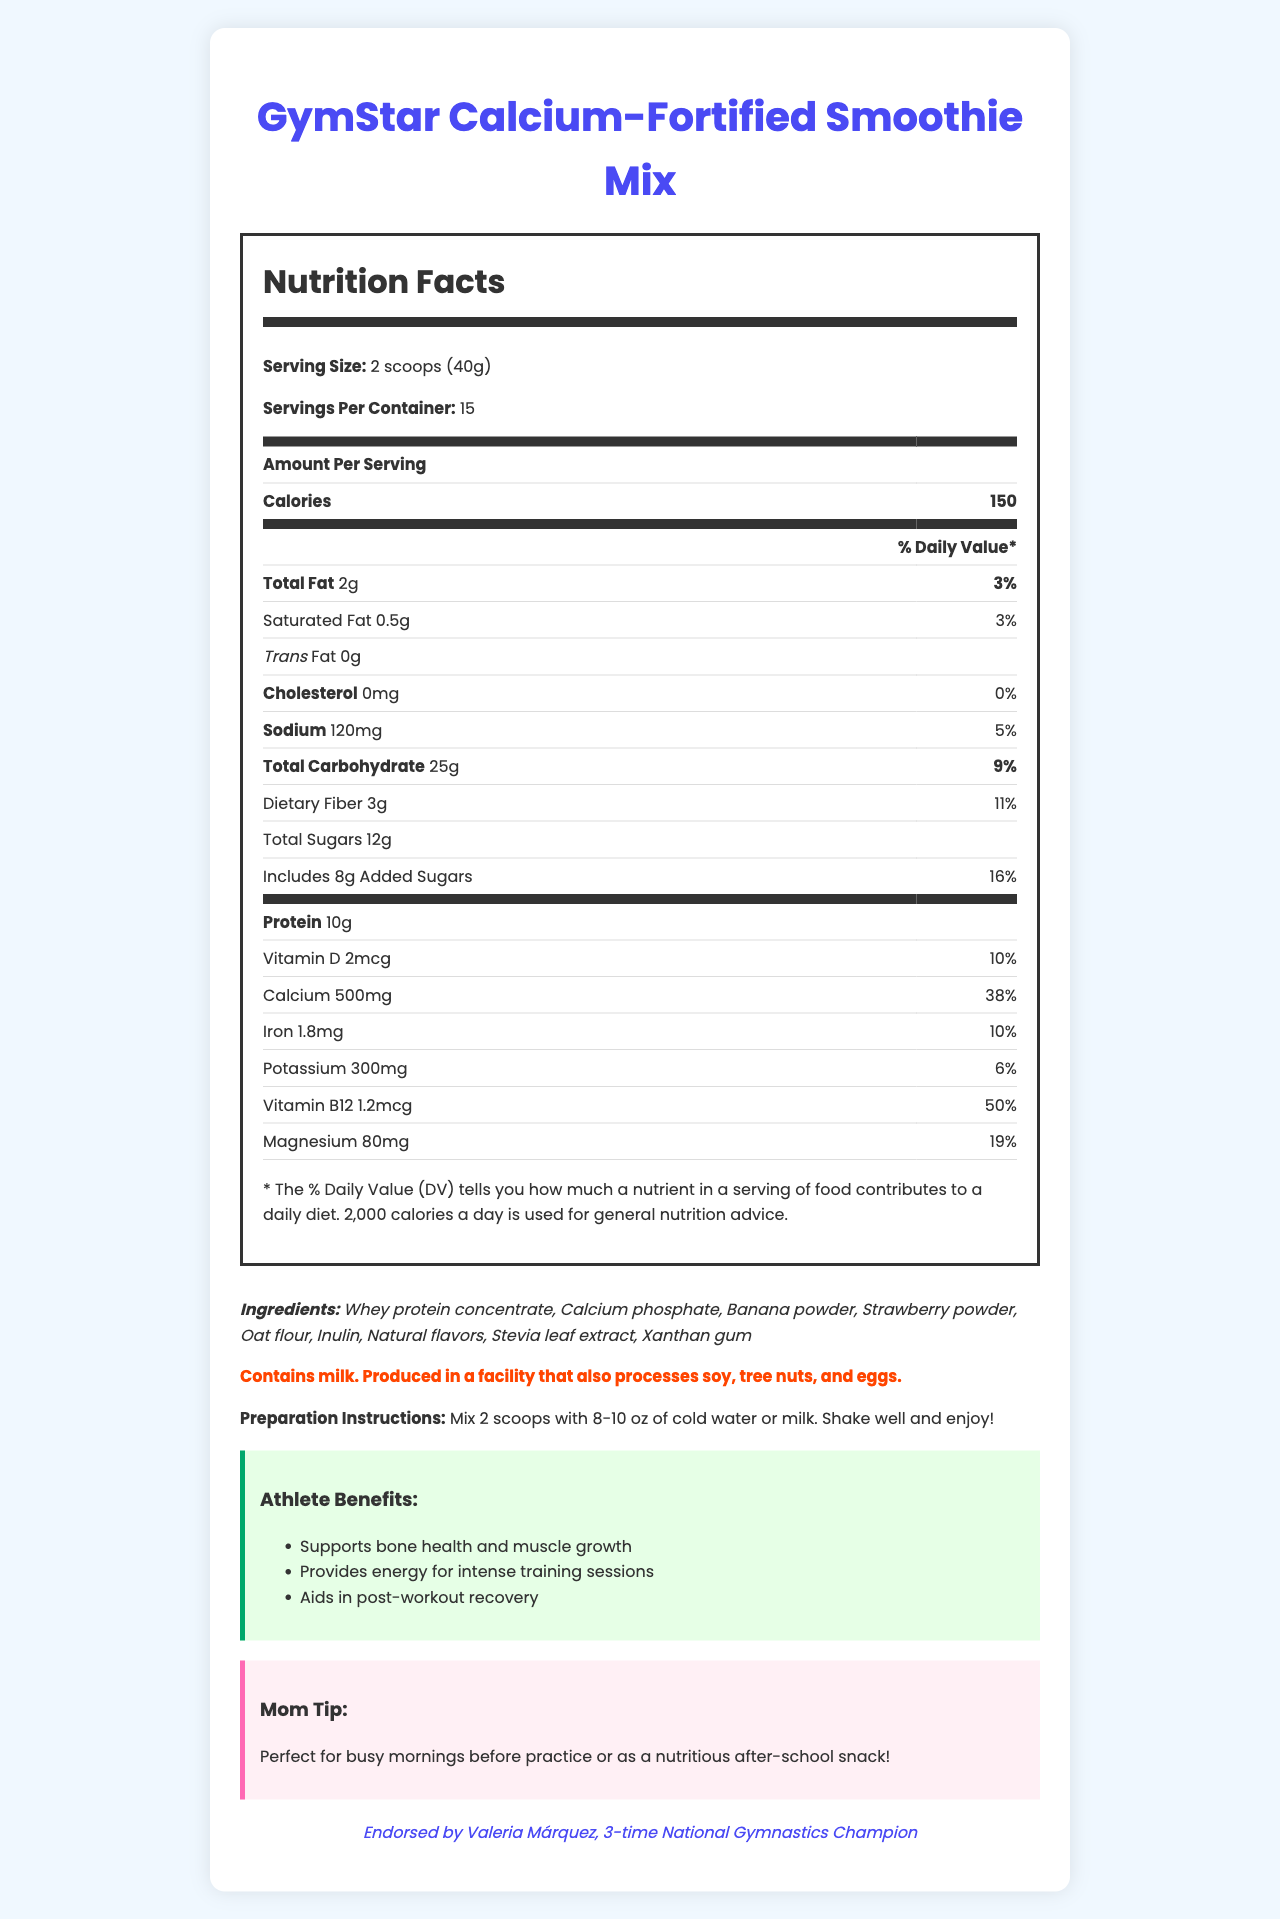what is the serving size of the GymStar Smoothie Mix? The Nutrition Facts label lists the serving size as "2 scoops (40g)".
Answer: 2 scoops (40g) how many calories are in one serving of the smoothie mix? The Nutrition Facts label states that each serving contains 150 calories.
Answer: 150 what is the percentage of daily value for calcium per serving? The Nutrition Facts label shows that each serving provides 38% of the daily value for calcium.
Answer: 38% how much protein does one serving contain? According to the Nutrition Facts label, one serving contains 10g of protein.
Answer: 10g what is the total carbohydrate content in one serving? The Nutrition Facts label indicates that the total carbohydrate content per serving is 25g.
Answer: 25g which ingredient in the GymStar Smoothie Mix acts as a natural sweetener? A. Stevia leaf extract B. Banana powder C. Inulin The ingredients list includes Stevia leaf extract, which is a natural sweetener.
Answer: A. Stevia leaf extract what is the primary flavor component of the GymStar Smoothie Mix? A. Strawberry powder B. Banana powder C. Natural flavors D. All of the above The ingredients list highlights banana powder, strawberry powder, and natural flavors—all contributing to the flavor.
Answer: D. All of the above does the GymStar Smoothie Mix contain any cholesterol? The label shows that the product contains 0mg of cholesterol, indicating it does not contain any.
Answer: No is the GymStar Smoothie Mix suitable for people with egg allergies? The allergen information specifies that the product is produced in a facility that processes eggs, making it unsuitable for those with egg allergies.
Answer: No summarize the purpose and benefits of the GymStar Smoothie Mix The product is outlined as a beneficial supplement for athletes, emphasizing its nutritional value, ease of preparation, and endorsement by a reputable athlete.
Answer: The GymStar Calcium-Fortified Smoothie Mix is designed to support growing athletes by promoting bone health, providing energy, and aiding in muscle recovery. It contains 150 calories per serving with key nutrients like calcium, protein, and vitamin B12. The preparation is easy—mix 2 scoops with cold water or milk. It is endorsed by Valeria Márquez, a notable gymnast, offering reassurance on its efficacy for athletic performance. who endorses the GymStar Smoothie Mix? The document states that the product is endorsed by Valeria Márquez, a 3-time National Gymnastics Champion.
Answer: Valeria Márquez, 3-time National Gymnastics Champion what is the total amount of dietary fiber per serving? The Nutrition Facts label indicates that there are 3g of dietary fiber per serving.
Answer: 3g how many grams of total sugars are in one serving? According to the Nutrition Facts label, one serving contains 12g of total sugars.
Answer: 12g does the GymStar Smoothie Mix contain soy? The allergen information states the product is produced in a facility that processes soy, but it does not confirm whether the mix itself contains soy.
Answer: Not enough information what is the daily value percentage for magnesium in one serving? The Nutrition Facts label specifies that one serving provides 19% of the daily value for magnesium.
Answer: 19% what is the allergen information for the GymStar Smoothie Mix? The allergen information is clearly outlined in the document stating it contains milk and is produced in a facility processing other common allergens.
Answer: Contains milk. Produced in a facility that also processes soy, tree nuts, and eggs. how much potassium is provided in a single serving of the GymStar Smoothie Mix? The Nutrition Facts label lists the potassium content as 300mg per serving.
Answer: 300mg 